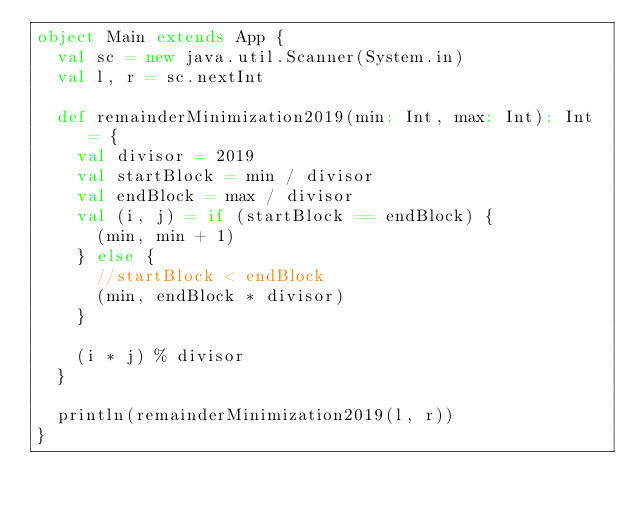<code> <loc_0><loc_0><loc_500><loc_500><_Scala_>object Main extends App {
  val sc = new java.util.Scanner(System.in)
  val l, r = sc.nextInt

  def remainderMinimization2019(min: Int, max: Int): Int = {
    val divisor = 2019
    val startBlock = min / divisor
    val endBlock = max / divisor
    val (i, j) = if (startBlock == endBlock) {
      (min, min + 1)
    } else {
      //startBlock < endBlock
      (min, endBlock * divisor)
    }

    (i * j) % divisor
  }

  println(remainderMinimization2019(l, r))
}</code> 